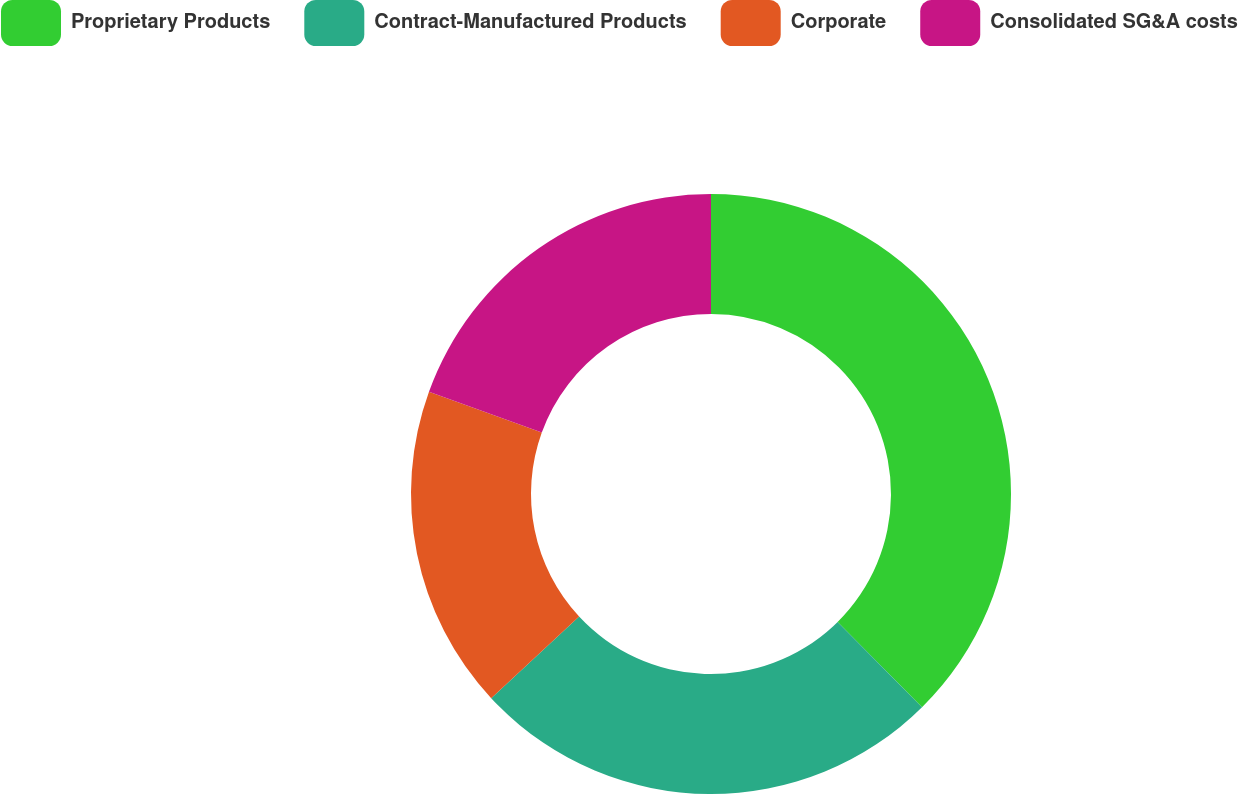Convert chart. <chart><loc_0><loc_0><loc_500><loc_500><pie_chart><fcel>Proprietary Products<fcel>Contract-Manufactured Products<fcel>Corporate<fcel>Consolidated SG&A costs<nl><fcel>37.58%<fcel>25.5%<fcel>17.45%<fcel>19.46%<nl></chart> 